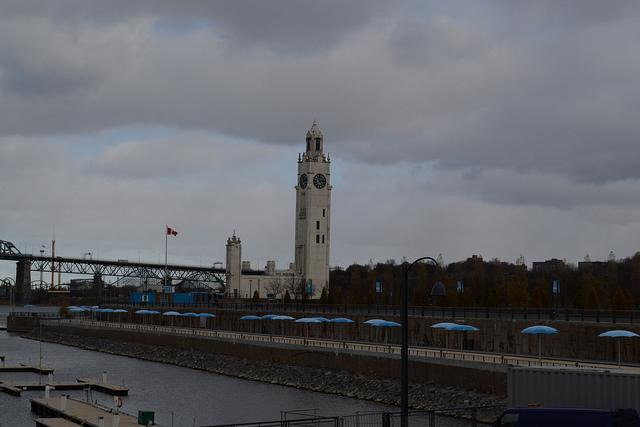Is it a nice day?
Concise answer only. No. Is this day sunny?
Quick response, please. No. Are there any umbrellas next to the river?
Answer briefly. Yes. What time of the day was the pic taken?
Concise answer only. Evening. 